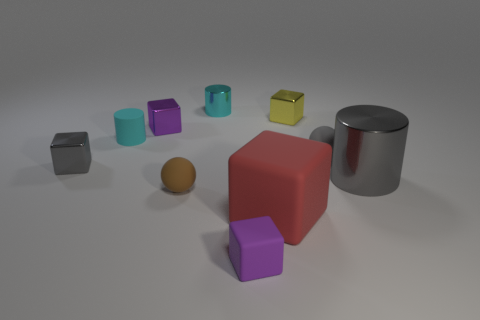There is a small purple thing that is the same material as the large cylinder; what is its shape?
Give a very brief answer. Cube. The tiny gray object that is right of the small cylinder on the left side of the small cyan shiny cylinder is made of what material?
Offer a terse response. Rubber. Does the small purple object behind the gray block have the same shape as the tiny yellow thing?
Keep it short and to the point. Yes. Is the number of tiny purple rubber objects in front of the tiny yellow object greater than the number of large blue shiny things?
Your answer should be very brief. Yes. What shape is the metallic thing that is the same color as the small matte block?
Give a very brief answer. Cube. How many cubes are small cyan shiny things or gray rubber things?
Give a very brief answer. 0. What is the color of the large thing left of the metallic cylinder in front of the yellow shiny thing?
Provide a succinct answer. Red. Do the small shiny cylinder and the small cylinder in front of the tiny yellow shiny thing have the same color?
Keep it short and to the point. Yes. The red thing that is the same material as the brown thing is what size?
Your answer should be compact. Large. Is the color of the matte cylinder the same as the small shiny cylinder?
Give a very brief answer. Yes. 